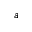Convert formula to latex. <formula><loc_0><loc_0><loc_500><loc_500>a</formula> 